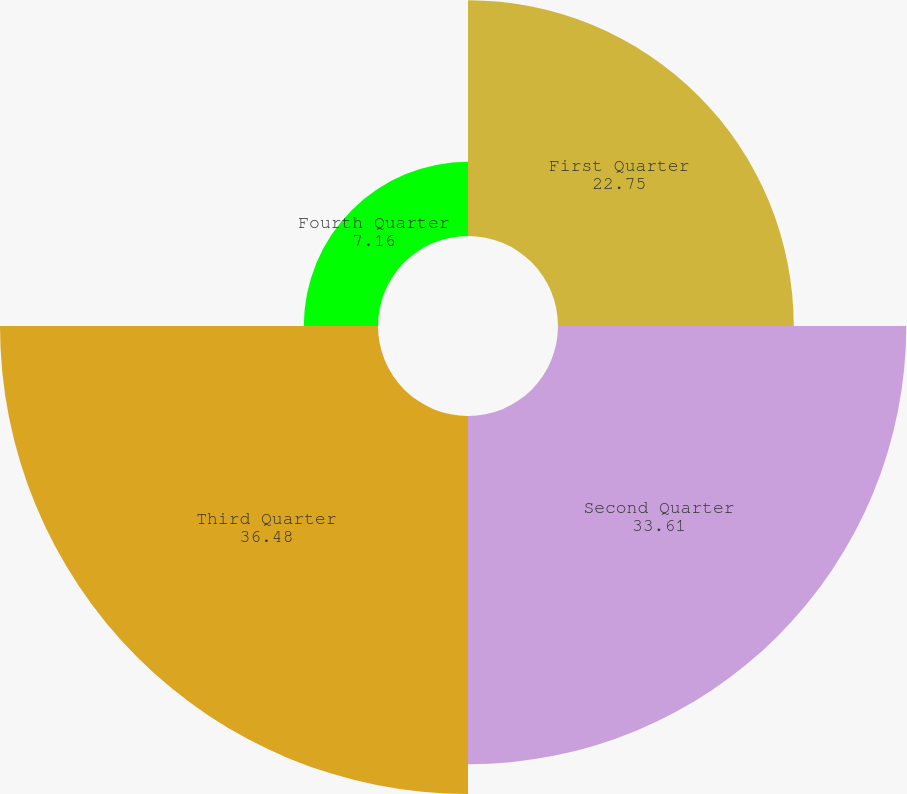Convert chart to OTSL. <chart><loc_0><loc_0><loc_500><loc_500><pie_chart><fcel>First Quarter<fcel>Second Quarter<fcel>Third Quarter<fcel>Fourth Quarter<nl><fcel>22.75%<fcel>33.61%<fcel>36.48%<fcel>7.16%<nl></chart> 